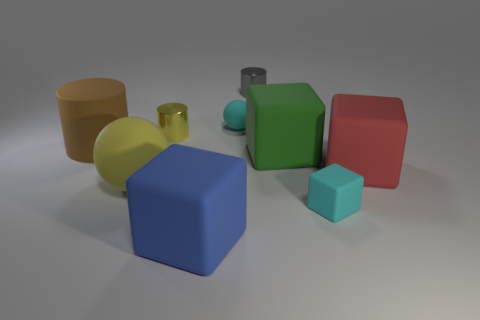Are there more yellow balls behind the small cyan cube than large blue shiny cylinders?
Offer a very short reply. Yes. Does the matte ball that is in front of the large matte cylinder have the same color as the tiny sphere?
Give a very brief answer. No. Is there anything else that is the same color as the small matte sphere?
Provide a short and direct response. Yes. What color is the small shiny thing that is on the left side of the tiny rubber object on the left side of the tiny cylinder that is to the right of the blue matte thing?
Your response must be concise. Yellow. Is the cyan ball the same size as the brown rubber cylinder?
Provide a short and direct response. No. What number of cyan rubber spheres are the same size as the brown thing?
Your answer should be compact. 0. There is a tiny object that is the same color as the tiny rubber ball; what is its shape?
Your answer should be very brief. Cube. Is the material of the tiny cyan object that is in front of the large red cube the same as the yellow object behind the green block?
Give a very brief answer. No. What color is the large rubber sphere?
Your answer should be very brief. Yellow. How many brown rubber objects are the same shape as the tiny yellow object?
Make the answer very short. 1. 